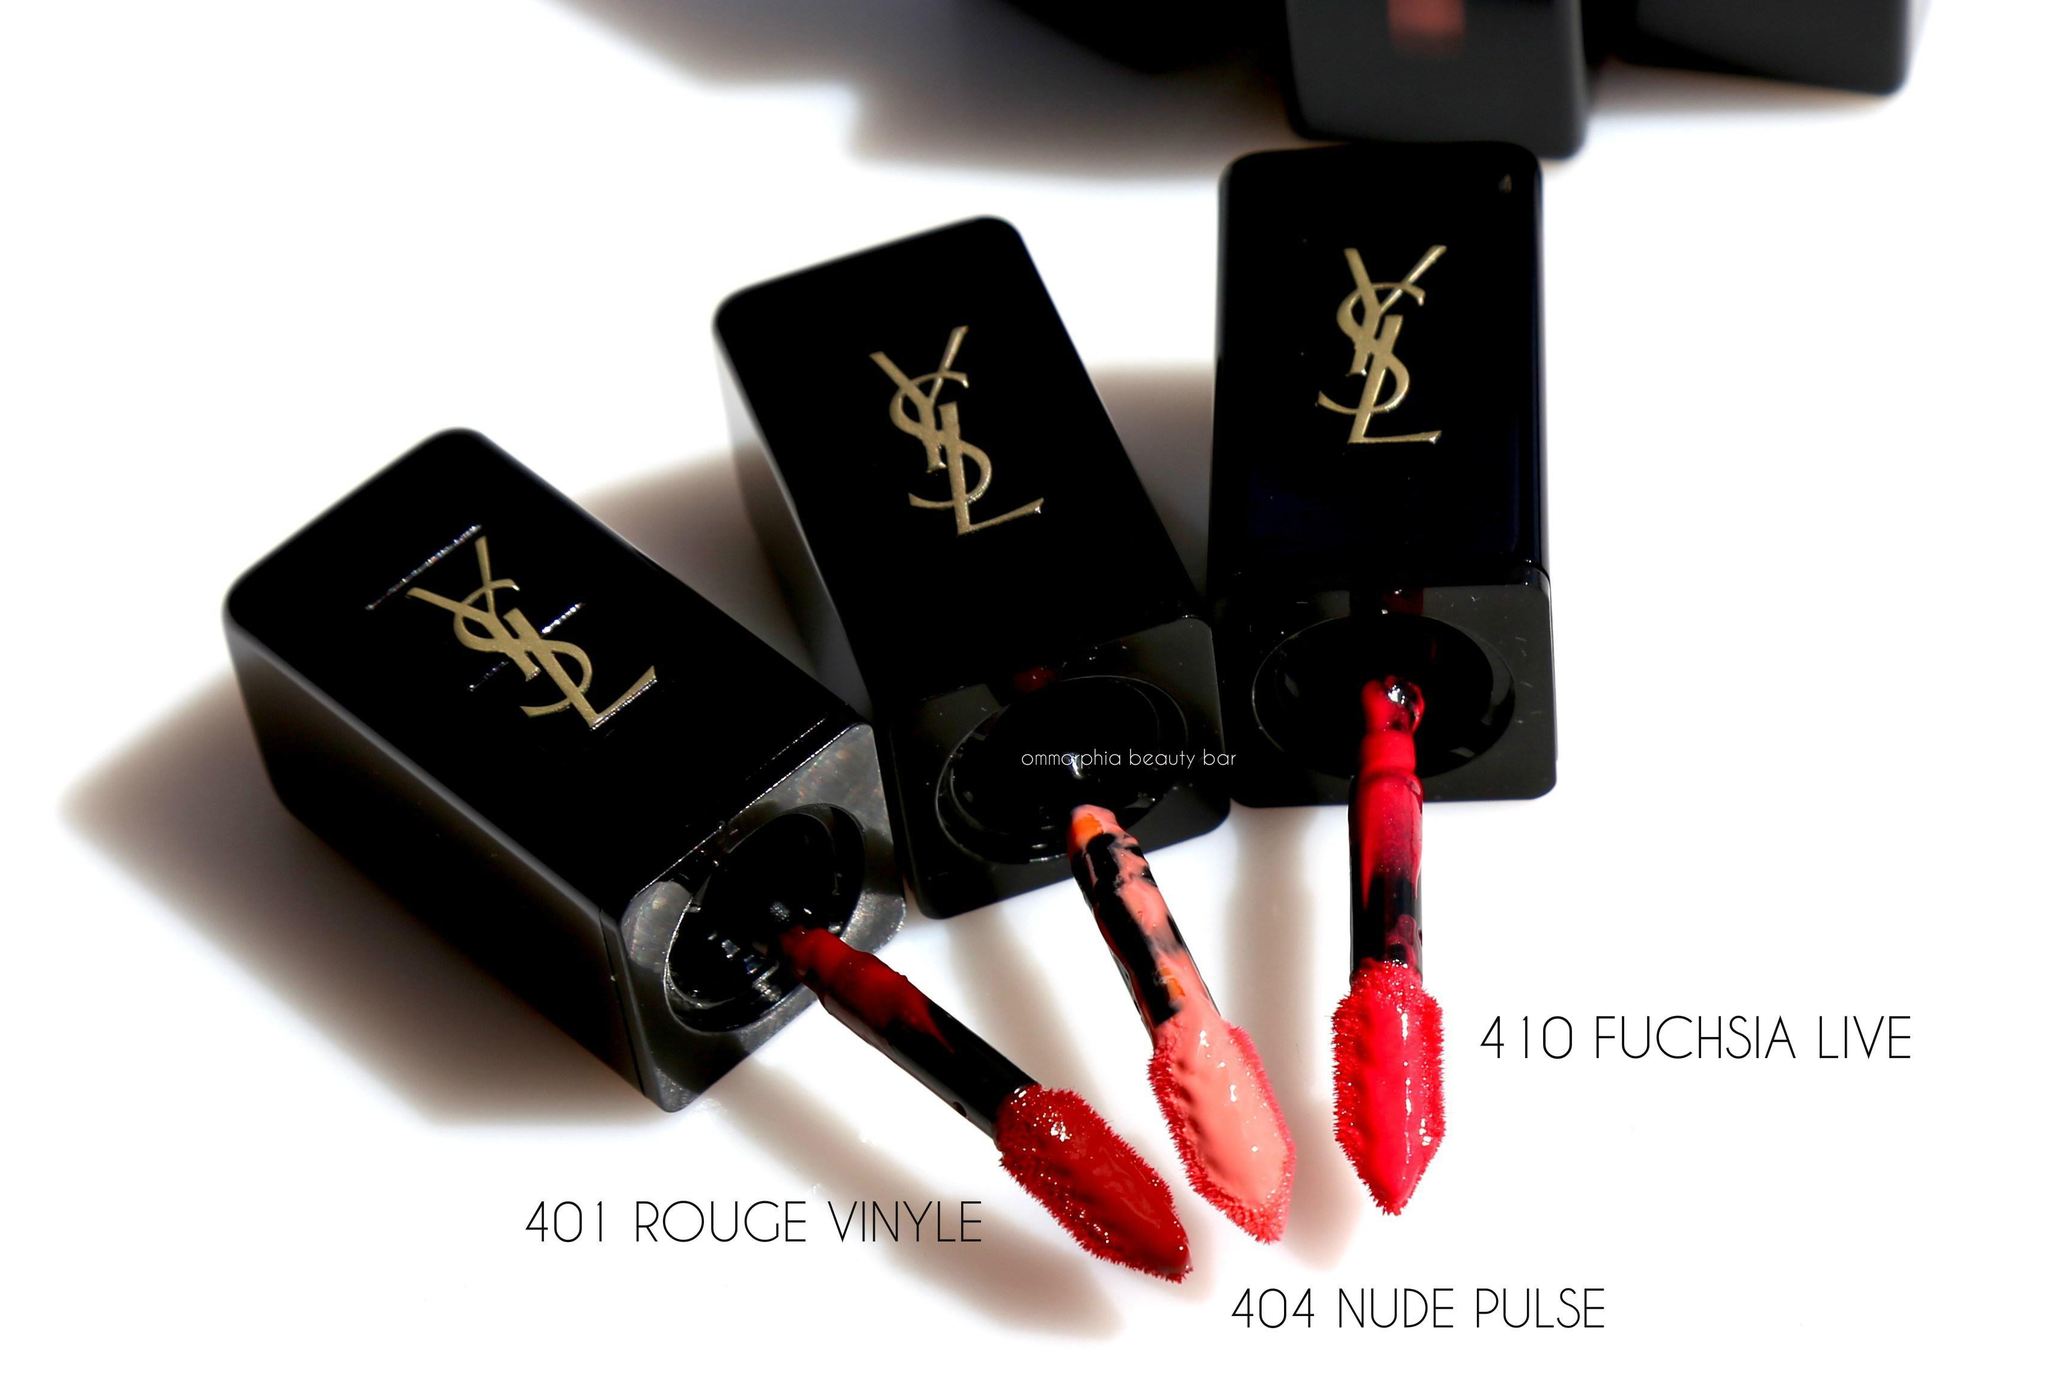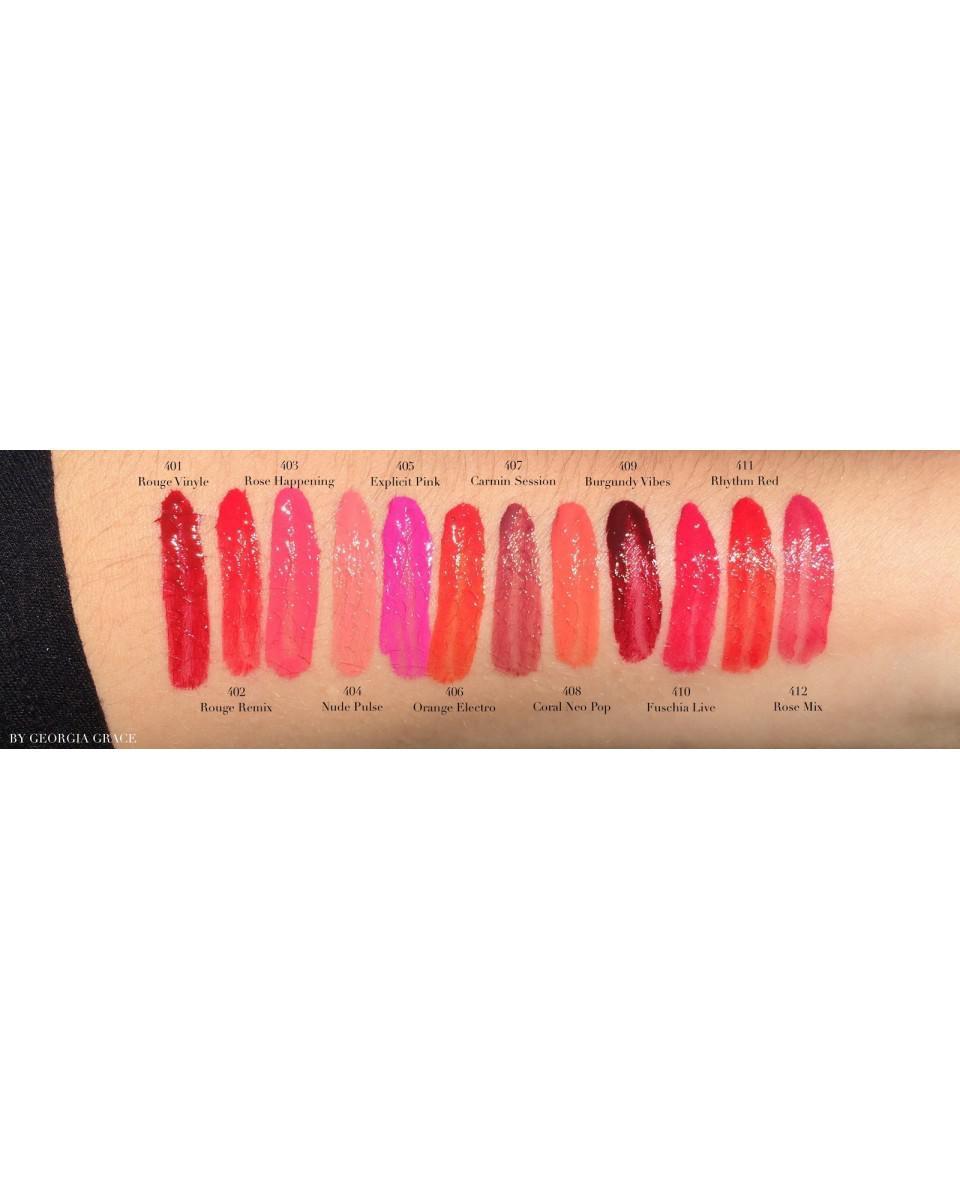The first image is the image on the left, the second image is the image on the right. Examine the images to the left and right. Is the description "In one image, a woman's lips are visible with lip makeup" accurate? Answer yes or no. No. The first image is the image on the left, the second image is the image on the right. Given the left and right images, does the statement "A single set of lips is shown under a tube of lipstick in one of the images." hold true? Answer yes or no. No. 